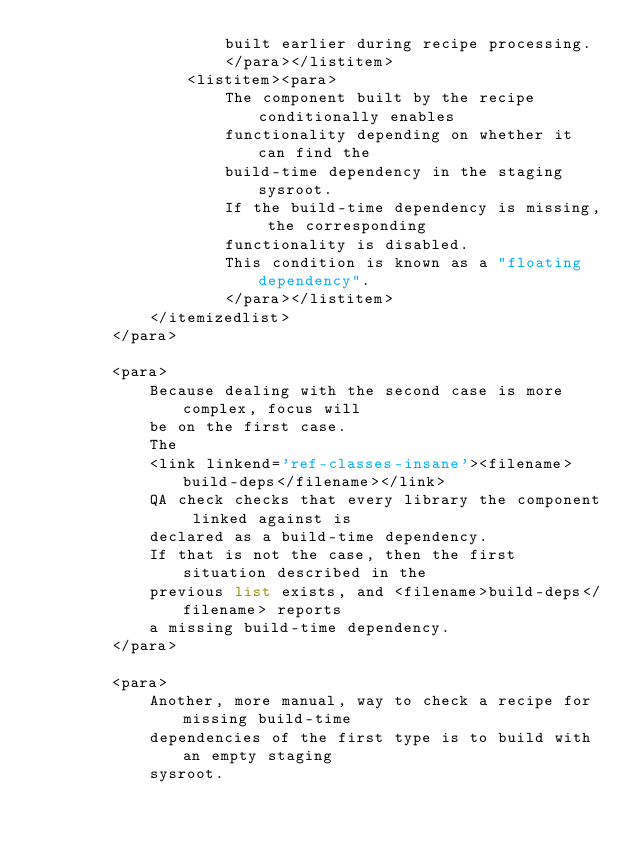<code> <loc_0><loc_0><loc_500><loc_500><_XML_>                    built earlier during recipe processing.
                    </para></listitem>
                <listitem><para>
                    The component built by the recipe conditionally enables
                    functionality depending on whether it can find the
                    build-time dependency in the staging sysroot.
                    If the build-time dependency is missing, the corresponding
                    functionality is disabled.
                    This condition is known as a "floating dependency".
                    </para></listitem>
            </itemizedlist>
        </para>

        <para>
            Because dealing with the second case is more complex, focus will
            be on the first case.
            The
            <link linkend='ref-classes-insane'><filename>build-deps</filename></link>
            QA check checks that every library the component linked against is
            declared as a build-time dependency.
            If that is not the case, then the first situation described in the
            previous list exists, and <filename>build-deps</filename> reports
            a missing build-time dependency.
        </para>

        <para>
            Another, more manual, way to check a recipe for missing build-time
            dependencies of the first type is to build with an empty staging
            sysroot.</code> 